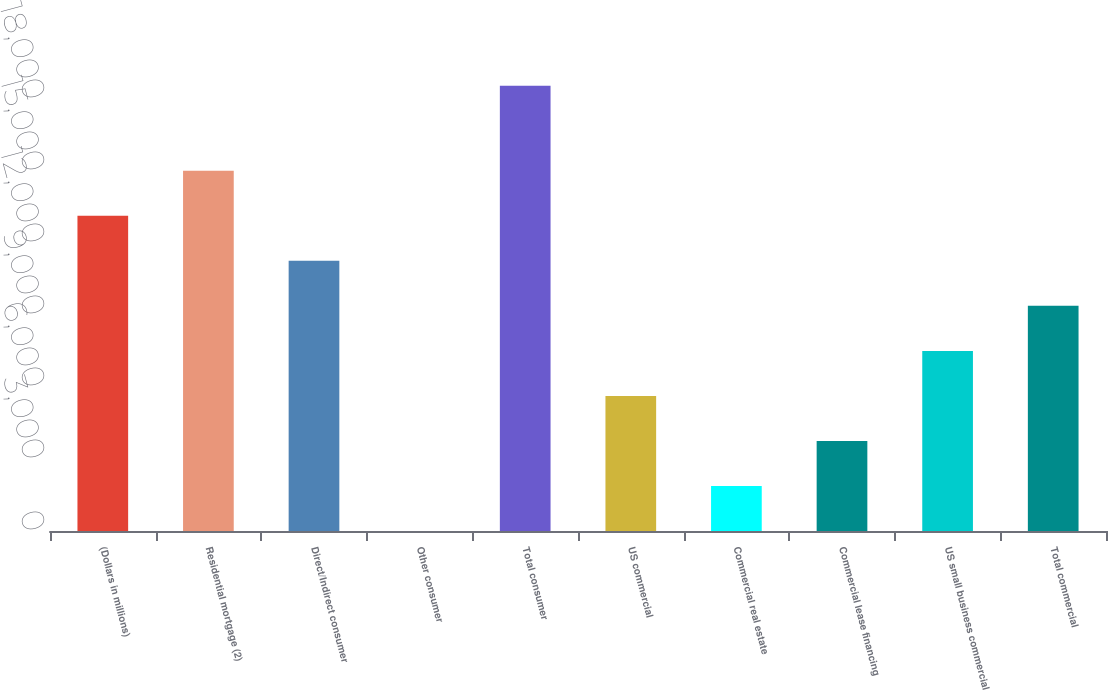Convert chart to OTSL. <chart><loc_0><loc_0><loc_500><loc_500><bar_chart><fcel>(Dollars in millions)<fcel>Residential mortgage (2)<fcel>Direct/Indirect consumer<fcel>Other consumer<fcel>Total consumer<fcel>US commercial<fcel>Commercial real estate<fcel>Commercial lease financing<fcel>US small business commercial<fcel>Total commercial<nl><fcel>13131.9<fcel>15007.6<fcel>11256.2<fcel>2<fcel>18555<fcel>5629.1<fcel>1877.7<fcel>3753.4<fcel>7504.8<fcel>9380.5<nl></chart> 